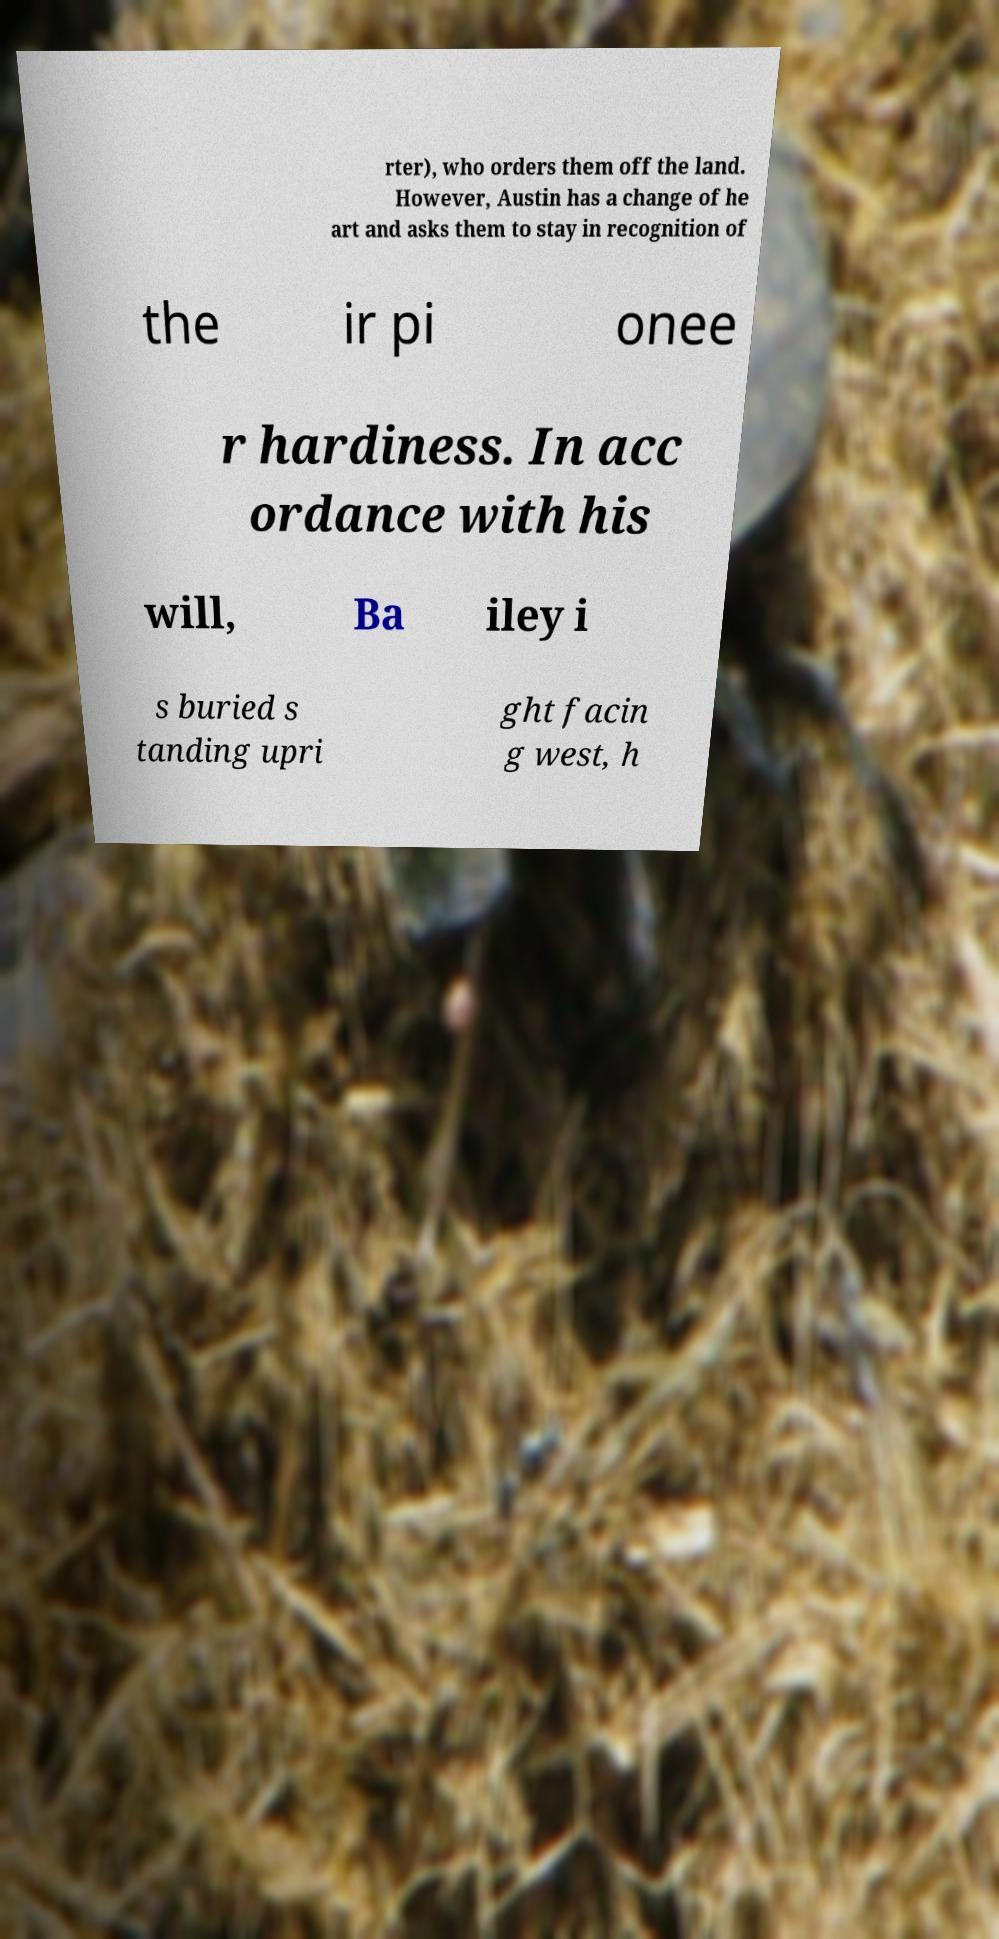I need the written content from this picture converted into text. Can you do that? rter), who orders them off the land. However, Austin has a change of he art and asks them to stay in recognition of the ir pi onee r hardiness. In acc ordance with his will, Ba iley i s buried s tanding upri ght facin g west, h 